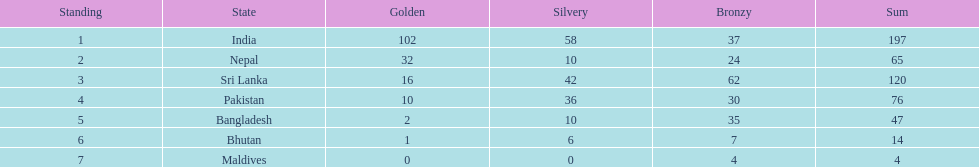Which nation has earned the least amount of gold medals? Maldives. Parse the table in full. {'header': ['Standing', 'State', 'Golden', 'Silvery', 'Bronzy', 'Sum'], 'rows': [['1', 'India', '102', '58', '37', '197'], ['2', 'Nepal', '32', '10', '24', '65'], ['3', 'Sri Lanka', '16', '42', '62', '120'], ['4', 'Pakistan', '10', '36', '30', '76'], ['5', 'Bangladesh', '2', '10', '35', '47'], ['6', 'Bhutan', '1', '6', '7', '14'], ['7', 'Maldives', '0', '0', '4', '4']]} 